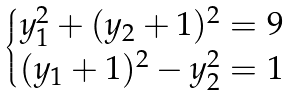Convert formula to latex. <formula><loc_0><loc_0><loc_500><loc_500>\begin{cases} y _ { 1 } ^ { 2 } + ( y _ { 2 } + 1 ) ^ { 2 } = 9 \\ ( y _ { 1 } + 1 ) ^ { 2 } - y _ { 2 } ^ { 2 } = 1 \end{cases}</formula> 